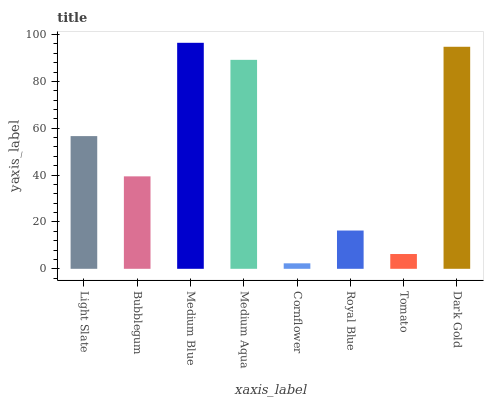Is Bubblegum the minimum?
Answer yes or no. No. Is Bubblegum the maximum?
Answer yes or no. No. Is Light Slate greater than Bubblegum?
Answer yes or no. Yes. Is Bubblegum less than Light Slate?
Answer yes or no. Yes. Is Bubblegum greater than Light Slate?
Answer yes or no. No. Is Light Slate less than Bubblegum?
Answer yes or no. No. Is Light Slate the high median?
Answer yes or no. Yes. Is Bubblegum the low median?
Answer yes or no. Yes. Is Bubblegum the high median?
Answer yes or no. No. Is Royal Blue the low median?
Answer yes or no. No. 